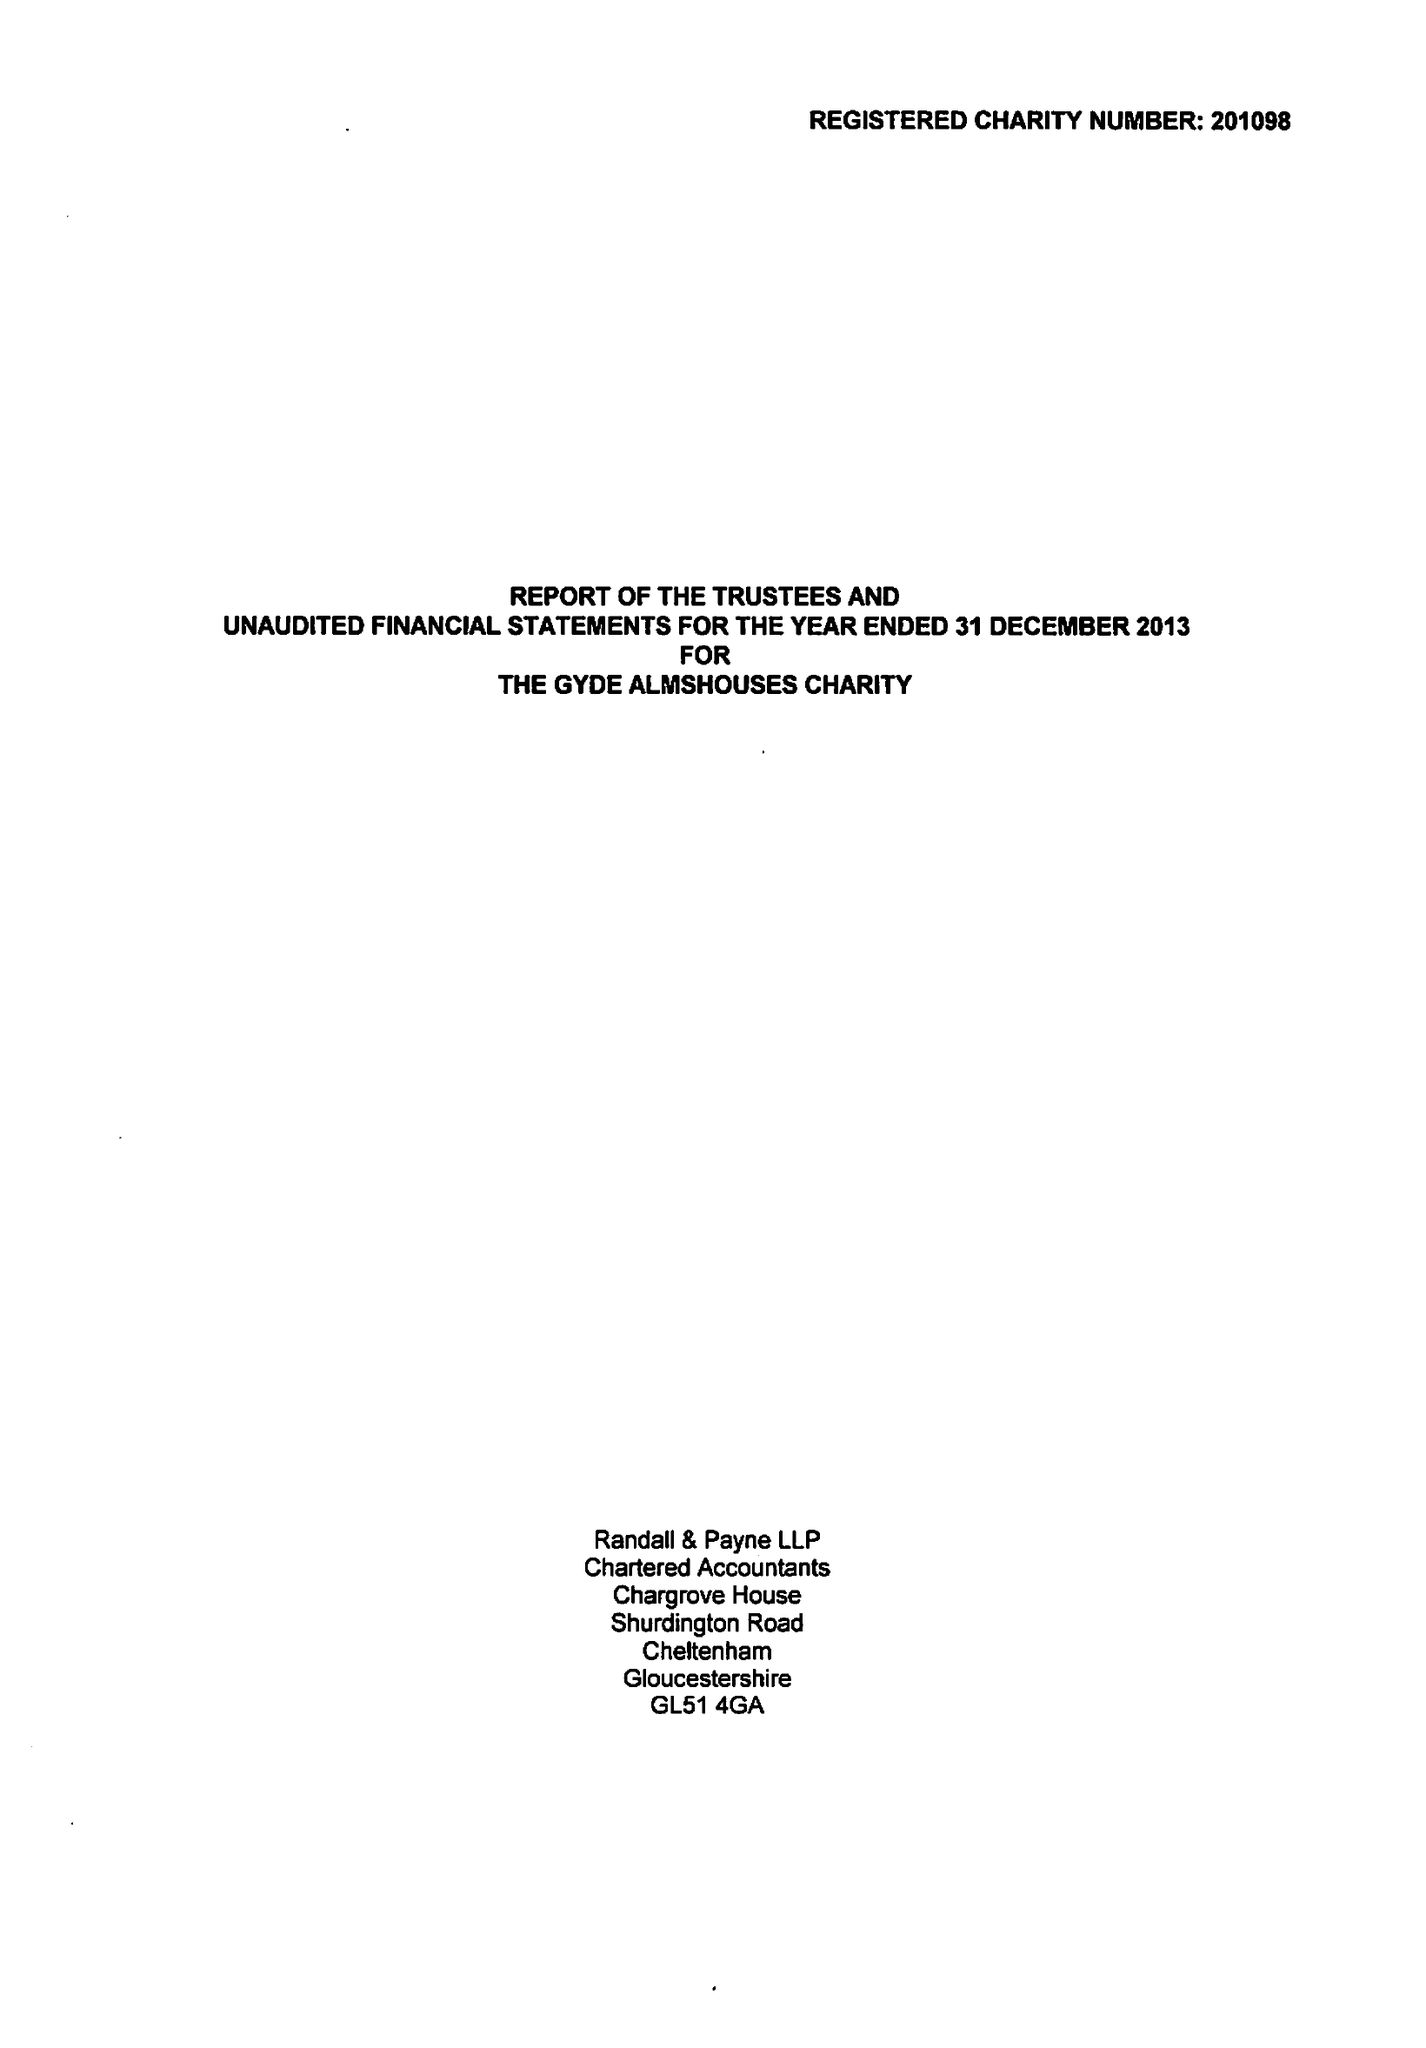What is the value for the address__post_town?
Answer the question using a single word or phrase. WOTTON-UNDER-EDGE 